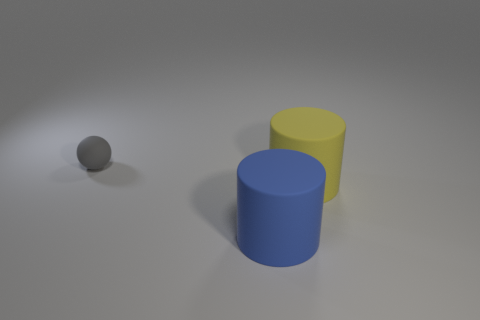Add 2 red rubber cylinders. How many objects exist? 5 Subtract all cylinders. How many objects are left? 1 Add 1 large yellow rubber cylinders. How many large yellow rubber cylinders exist? 2 Subtract 0 brown blocks. How many objects are left? 3 Subtract all gray objects. Subtract all big blue cylinders. How many objects are left? 1 Add 2 spheres. How many spheres are left? 3 